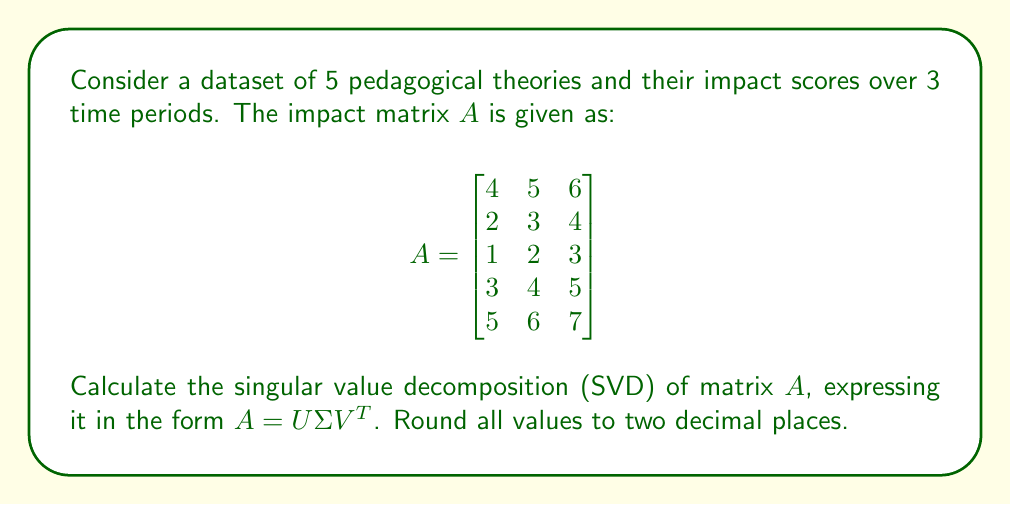Can you solve this math problem? To find the SVD of matrix $A$, we follow these steps:

1) First, calculate $A^TA$ and $AA^T$:

   $A^TA = \begin{bmatrix}
   55 & 70 & 85 \\
   70 & 90 & 110 \\
   85 & 110 & 135
   \end{bmatrix}$

   $AA^T = \begin{bmatrix}
   77 & 47 & 32 & 62 & 92 \\
   47 & 29 & 20 & 38 & 56 \\
   32 & 20 & 14 & 26 & 38 \\
   62 & 38 & 26 & 50 & 74 \\
   92 & 56 & 38 & 74 & 110
   \end{bmatrix}$

2) Find eigenvalues of $A^TA$:
   Characteristic equation: $\lambda^3 - 280\lambda^2 + 975\lambda = 0$
   Eigenvalues: $\lambda_1 = 275.26$, $\lambda_2 = 4.74$, $\lambda_3 = 0$

3) Singular values are square roots of these eigenvalues:
   $\sigma_1 = \sqrt{275.26} \approx 16.59$
   $\sigma_2 = \sqrt{4.74} \approx 2.18$
   $\sigma_3 = 0$

4) Find eigenvectors of $A^TA$ (columns of $V$):
   $v_1 \approx [0.50, 0.64, 0.58]^T$
   $v_2 \approx [-0.76, 0.09, 0.64]^T$
   $v_3 \approx [0.41, -0.76, 0.50]^T$

5) Find eigenvectors of $AA^T$ (columns of $U$):
   $u_1 \approx [0.56, 0.34, 0.23, 0.45, 0.56]^T$
   $u_2 \approx [-0.41, -0.49, -0.37, 0.62, 0.25]^T$
   (The remaining columns can be any orthonormal basis for the null space)

6) Construct matrices $U$, $\Sigma$, and $V$:

   $U \approx \begin{bmatrix}
   0.56 & -0.41 & * & * & * \\
   0.34 & -0.49 & * & * & * \\
   0.23 & -0.37 & * & * & * \\
   0.45 & 0.62 & * & * & * \\
   0.56 & 0.25 & * & * & *
   \end{bmatrix}$

   $\Sigma = \begin{bmatrix}
   16.59 & 0 & 0 \\
   0 & 2.18 & 0 \\
   0 & 0 & 0 \\
   0 & 0 & 0 \\
   0 & 0 & 0
   \end{bmatrix}$

   $V \approx \begin{bmatrix}
   0.50 & -0.76 & 0.41 \\
   0.64 & 0.09 & -0.76 \\
   0.58 & 0.64 & 0.50
   \end{bmatrix}$

Thus, $A = U\Sigma V^T$ is the singular value decomposition of $A$.
Answer: $A = U\Sigma V^T$, where:

$U \approx \begin{bmatrix}
0.56 & -0.41 & * & * & * \\
0.34 & -0.49 & * & * & * \\
0.23 & -0.37 & * & * & * \\
0.45 & 0.62 & * & * & * \\
0.56 & 0.25 & * & * & *
\end{bmatrix}$

$\Sigma = \begin{bmatrix}
16.59 & 0 & 0 \\
0 & 2.18 & 0 \\
0 & 0 & 0 \\
0 & 0 & 0 \\
0 & 0 & 0
\end{bmatrix}$

$V \approx \begin{bmatrix}
0.50 & -0.76 & 0.41 \\
0.64 & 0.09 & -0.76 \\
0.58 & 0.64 & 0.50
\end{bmatrix}$ 